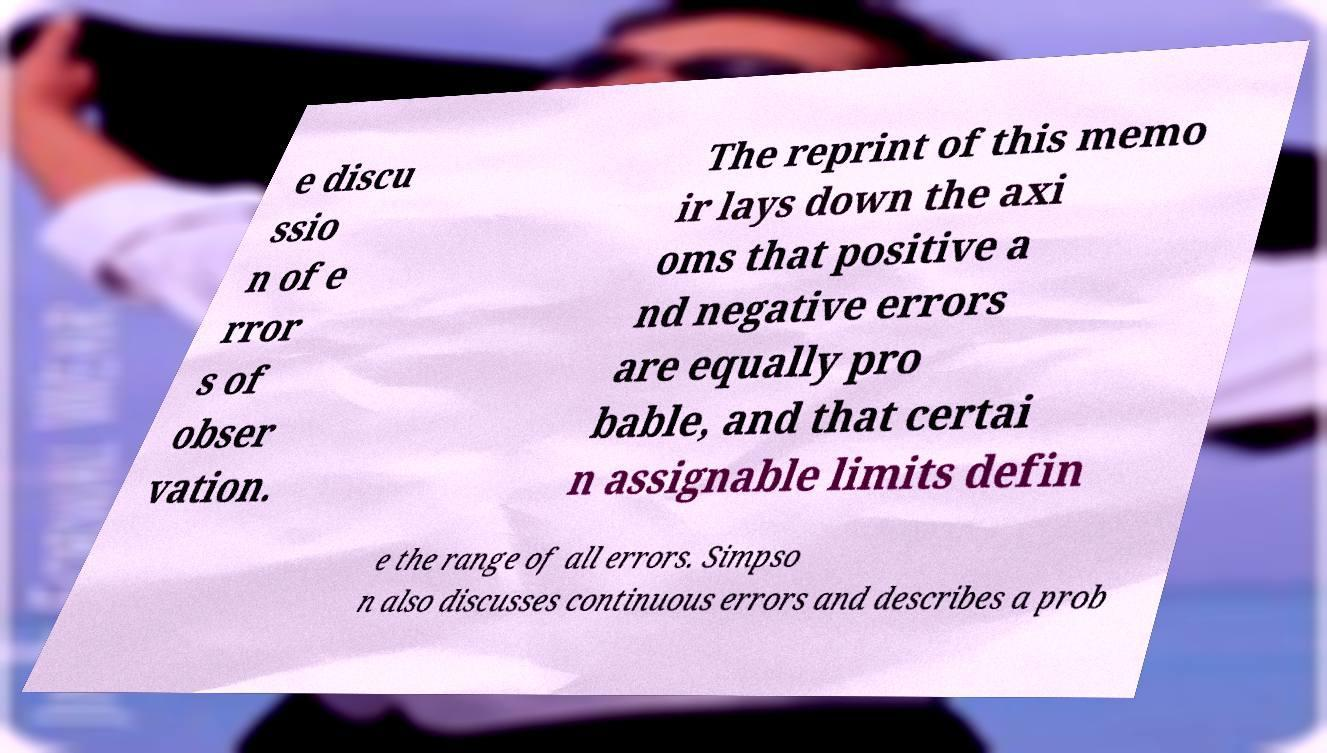For documentation purposes, I need the text within this image transcribed. Could you provide that? e discu ssio n of e rror s of obser vation. The reprint of this memo ir lays down the axi oms that positive a nd negative errors are equally pro bable, and that certai n assignable limits defin e the range of all errors. Simpso n also discusses continuous errors and describes a prob 